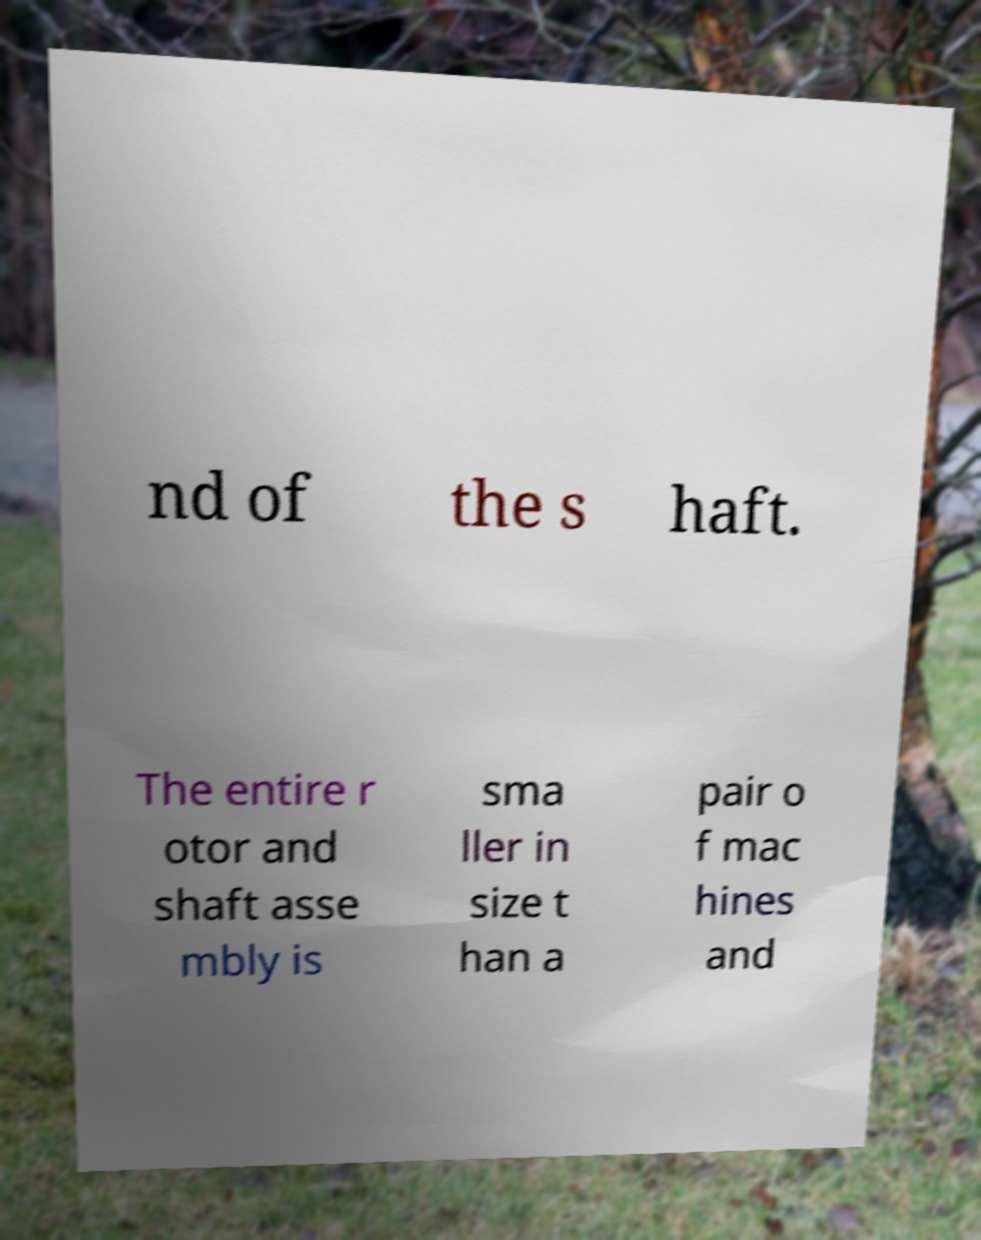Could you assist in decoding the text presented in this image and type it out clearly? nd of the s haft. The entire r otor and shaft asse mbly is sma ller in size t han a pair o f mac hines and 